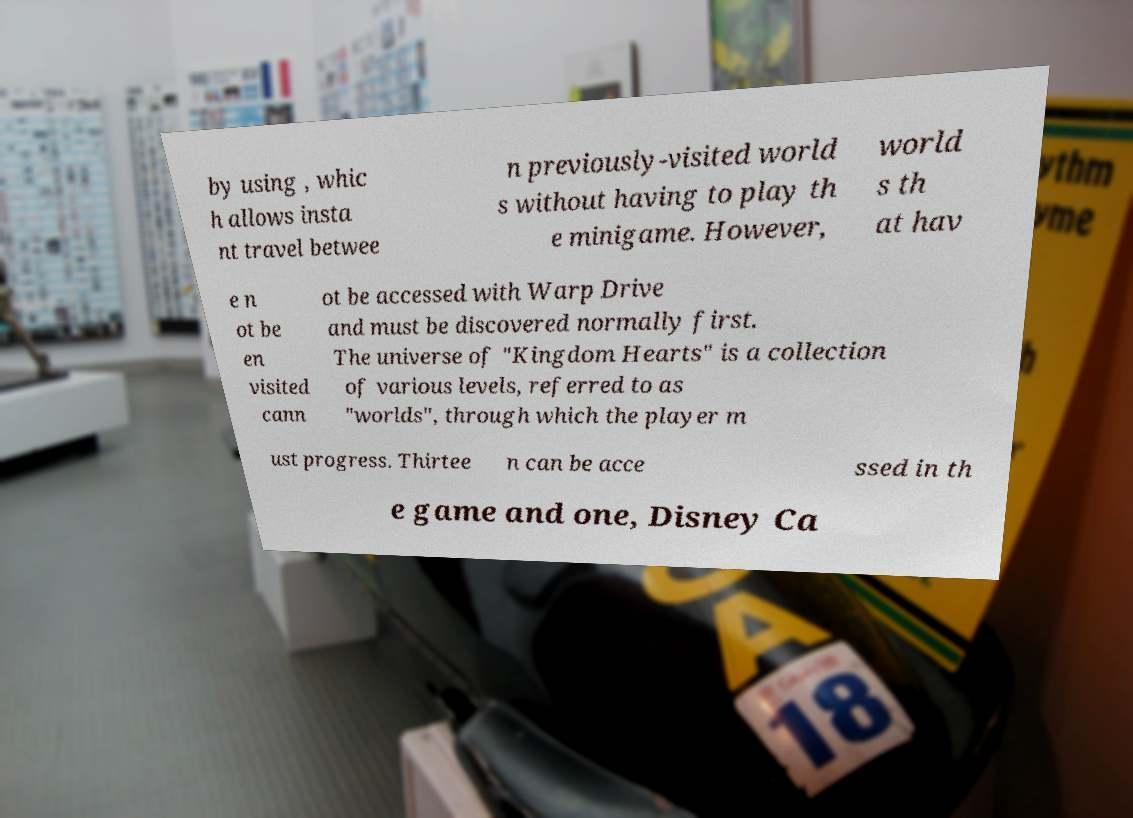Can you read and provide the text displayed in the image?This photo seems to have some interesting text. Can you extract and type it out for me? by using , whic h allows insta nt travel betwee n previously-visited world s without having to play th e minigame. However, world s th at hav e n ot be en visited cann ot be accessed with Warp Drive and must be discovered normally first. The universe of "Kingdom Hearts" is a collection of various levels, referred to as "worlds", through which the player m ust progress. Thirtee n can be acce ssed in th e game and one, Disney Ca 